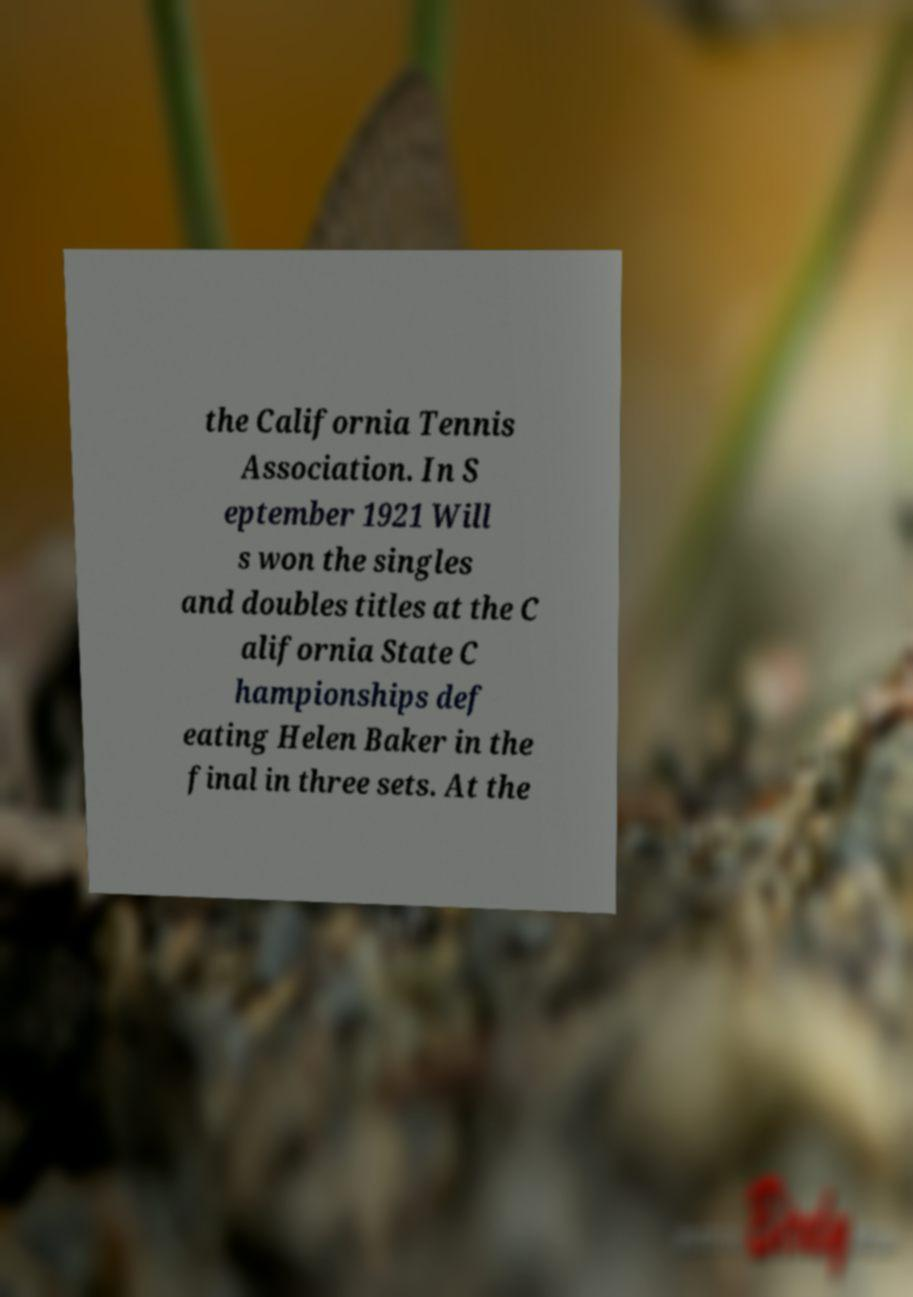Please read and relay the text visible in this image. What does it say? the California Tennis Association. In S eptember 1921 Will s won the singles and doubles titles at the C alifornia State C hampionships def eating Helen Baker in the final in three sets. At the 